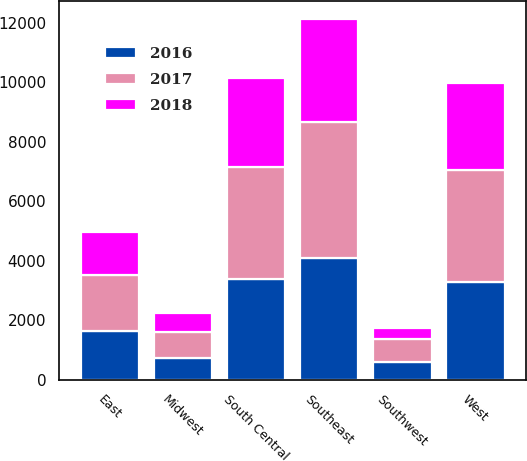<chart> <loc_0><loc_0><loc_500><loc_500><stacked_bar_chart><ecel><fcel>East<fcel>Midwest<fcel>Southeast<fcel>South Central<fcel>Southwest<fcel>West<nl><fcel>2017<fcel>1893.4<fcel>858.9<fcel>4578.6<fcel>3769.9<fcel>768.7<fcel>3754.3<nl><fcel>2016<fcel>1640.1<fcel>736.5<fcel>4087.6<fcel>3383.1<fcel>597.5<fcel>3296.7<nl><fcel>2018<fcel>1446.5<fcel>651.7<fcel>3463.5<fcel>2995.1<fcel>388.1<fcel>2916.9<nl></chart> 